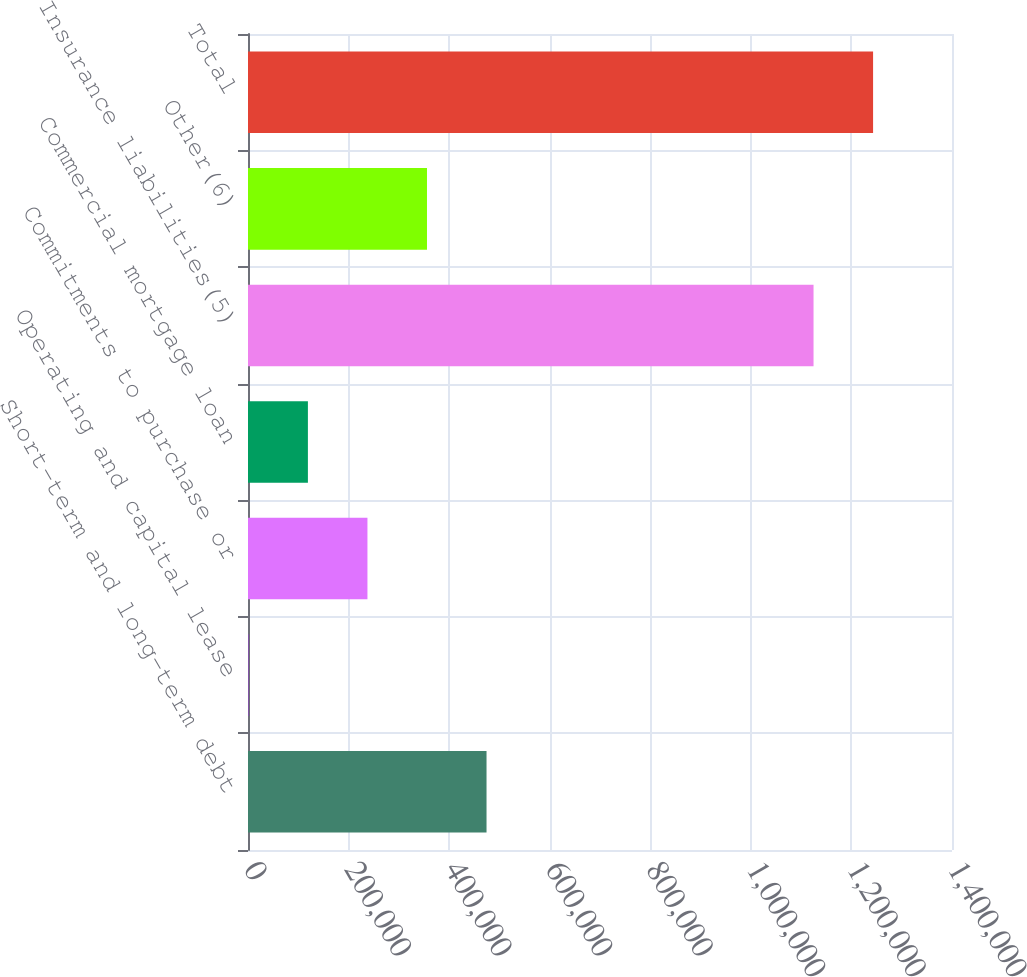Convert chart. <chart><loc_0><loc_0><loc_500><loc_500><bar_chart><fcel>Short-term and long-term debt<fcel>Operating and capital lease<fcel>Commitments to purchase or<fcel>Commercial mortgage loan<fcel>Insurance liabilities(5)<fcel>Other(6)<fcel>Total<nl><fcel>474355<fcel>718<fcel>237537<fcel>119127<fcel>1.12464e+06<fcel>355946<fcel>1.24305e+06<nl></chart> 